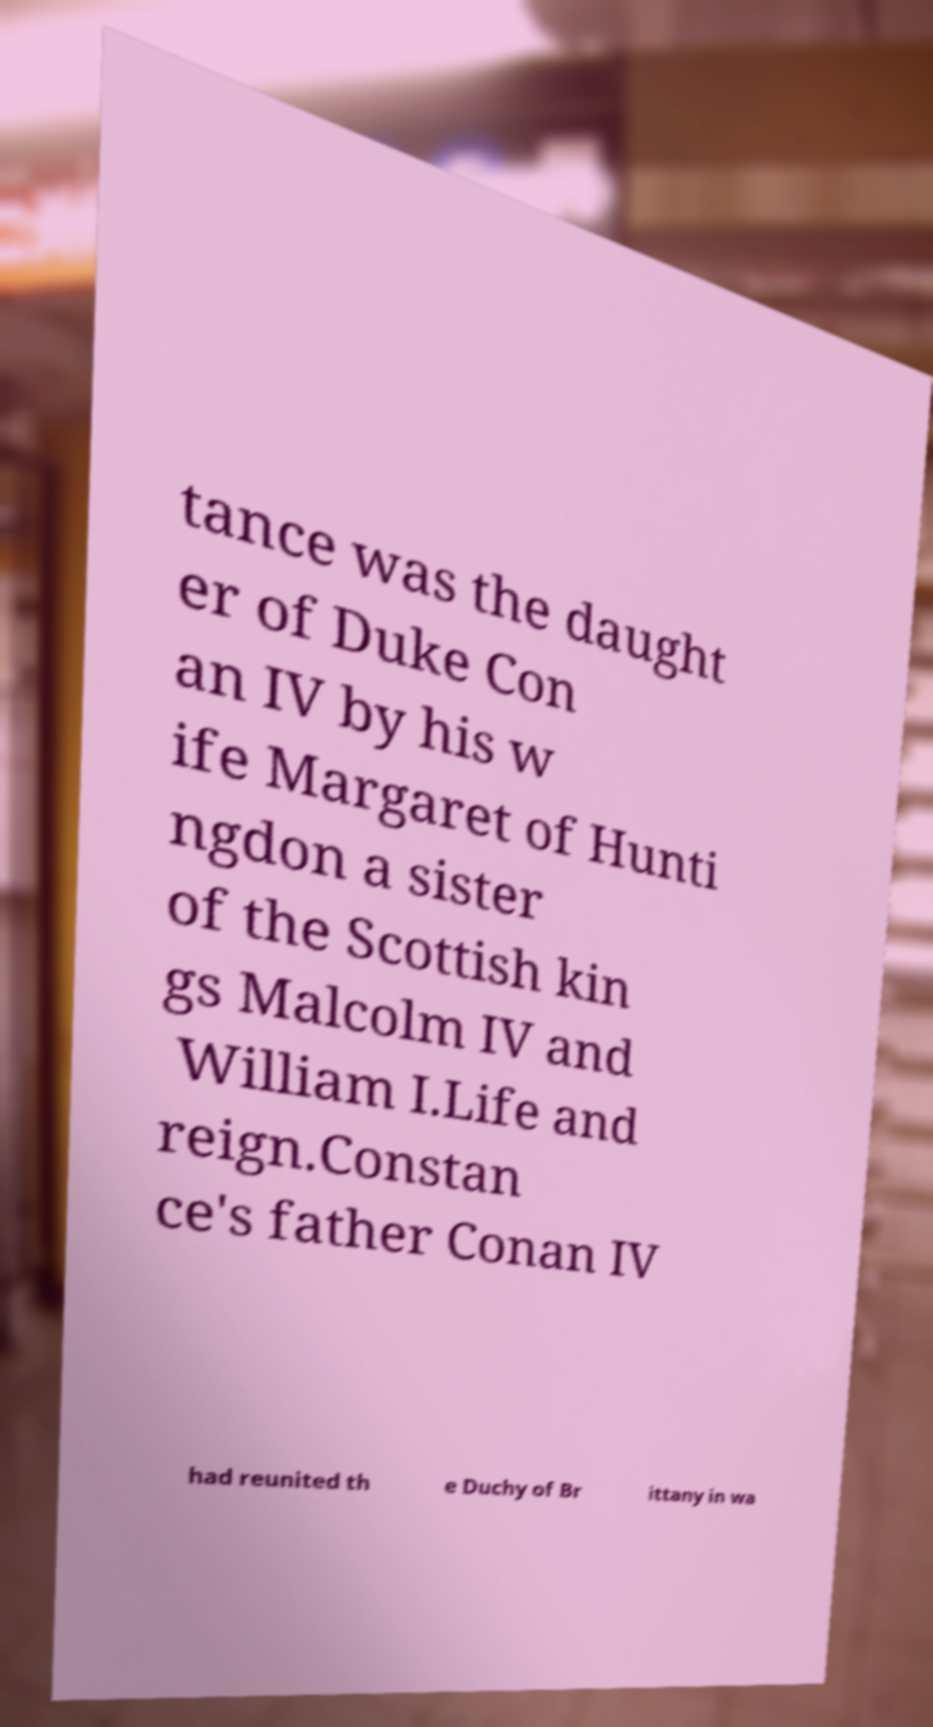Can you accurately transcribe the text from the provided image for me? tance was the daught er of Duke Con an IV by his w ife Margaret of Hunti ngdon a sister of the Scottish kin gs Malcolm IV and William I.Life and reign.Constan ce's father Conan IV had reunited th e Duchy of Br ittany in wa 